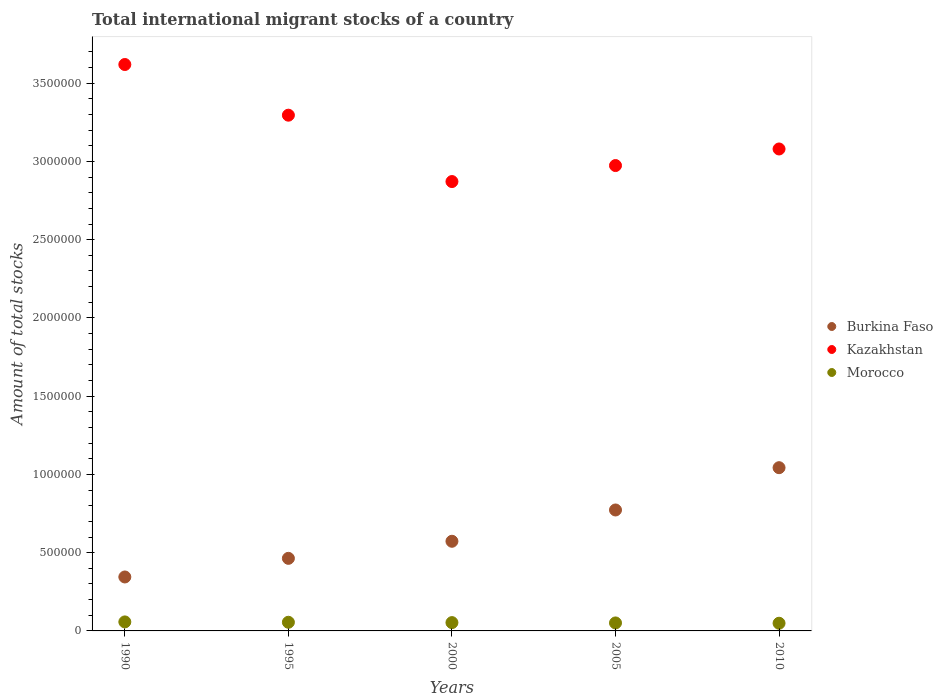How many different coloured dotlines are there?
Provide a short and direct response. 3. Is the number of dotlines equal to the number of legend labels?
Offer a terse response. Yes. What is the amount of total stocks in in Burkina Faso in 1990?
Your answer should be compact. 3.45e+05. Across all years, what is the maximum amount of total stocks in in Kazakhstan?
Provide a succinct answer. 3.62e+06. Across all years, what is the minimum amount of total stocks in in Kazakhstan?
Offer a terse response. 2.87e+06. In which year was the amount of total stocks in in Burkina Faso maximum?
Make the answer very short. 2010. What is the total amount of total stocks in in Morocco in the graph?
Your response must be concise. 2.66e+05. What is the difference between the amount of total stocks in in Burkina Faso in 2000 and that in 2010?
Give a very brief answer. -4.70e+05. What is the difference between the amount of total stocks in in Morocco in 2005 and the amount of total stocks in in Burkina Faso in 2000?
Offer a very short reply. -5.22e+05. What is the average amount of total stocks in in Morocco per year?
Ensure brevity in your answer.  5.32e+04. In the year 2005, what is the difference between the amount of total stocks in in Morocco and amount of total stocks in in Kazakhstan?
Offer a very short reply. -2.92e+06. What is the ratio of the amount of total stocks in in Kazakhstan in 1990 to that in 2000?
Offer a terse response. 1.26. Is the amount of total stocks in in Burkina Faso in 1990 less than that in 2000?
Keep it short and to the point. Yes. Is the difference between the amount of total stocks in in Morocco in 2005 and 2010 greater than the difference between the amount of total stocks in in Kazakhstan in 2005 and 2010?
Offer a terse response. Yes. What is the difference between the highest and the second highest amount of total stocks in in Kazakhstan?
Give a very brief answer. 3.24e+05. What is the difference between the highest and the lowest amount of total stocks in in Kazakhstan?
Your answer should be very brief. 7.48e+05. Is the sum of the amount of total stocks in in Kazakhstan in 1990 and 2010 greater than the maximum amount of total stocks in in Burkina Faso across all years?
Provide a short and direct response. Yes. Does the amount of total stocks in in Kazakhstan monotonically increase over the years?
Your answer should be compact. No. What is the difference between two consecutive major ticks on the Y-axis?
Keep it short and to the point. 5.00e+05. Are the values on the major ticks of Y-axis written in scientific E-notation?
Make the answer very short. No. Where does the legend appear in the graph?
Provide a succinct answer. Center right. How many legend labels are there?
Offer a terse response. 3. What is the title of the graph?
Provide a short and direct response. Total international migrant stocks of a country. Does "Hong Kong" appear as one of the legend labels in the graph?
Your answer should be very brief. No. What is the label or title of the X-axis?
Give a very brief answer. Years. What is the label or title of the Y-axis?
Your response must be concise. Amount of total stocks. What is the Amount of total stocks in Burkina Faso in 1990?
Provide a succinct answer. 3.45e+05. What is the Amount of total stocks of Kazakhstan in 1990?
Ensure brevity in your answer.  3.62e+06. What is the Amount of total stocks in Morocco in 1990?
Ensure brevity in your answer.  5.76e+04. What is the Amount of total stocks in Burkina Faso in 1995?
Give a very brief answer. 4.64e+05. What is the Amount of total stocks in Kazakhstan in 1995?
Provide a succinct answer. 3.30e+06. What is the Amount of total stocks of Morocco in 1995?
Keep it short and to the point. 5.53e+04. What is the Amount of total stocks of Burkina Faso in 2000?
Give a very brief answer. 5.73e+05. What is the Amount of total stocks of Kazakhstan in 2000?
Offer a very short reply. 2.87e+06. What is the Amount of total stocks in Morocco in 2000?
Provide a succinct answer. 5.31e+04. What is the Amount of total stocks of Burkina Faso in 2005?
Give a very brief answer. 7.73e+05. What is the Amount of total stocks in Kazakhstan in 2005?
Give a very brief answer. 2.97e+06. What is the Amount of total stocks of Morocco in 2005?
Provide a short and direct response. 5.10e+04. What is the Amount of total stocks in Burkina Faso in 2010?
Offer a terse response. 1.04e+06. What is the Amount of total stocks of Kazakhstan in 2010?
Your response must be concise. 3.08e+06. What is the Amount of total stocks of Morocco in 2010?
Your answer should be compact. 4.91e+04. Across all years, what is the maximum Amount of total stocks of Burkina Faso?
Ensure brevity in your answer.  1.04e+06. Across all years, what is the maximum Amount of total stocks of Kazakhstan?
Make the answer very short. 3.62e+06. Across all years, what is the maximum Amount of total stocks of Morocco?
Your response must be concise. 5.76e+04. Across all years, what is the minimum Amount of total stocks in Burkina Faso?
Ensure brevity in your answer.  3.45e+05. Across all years, what is the minimum Amount of total stocks in Kazakhstan?
Your response must be concise. 2.87e+06. Across all years, what is the minimum Amount of total stocks in Morocco?
Give a very brief answer. 4.91e+04. What is the total Amount of total stocks of Burkina Faso in the graph?
Provide a short and direct response. 3.20e+06. What is the total Amount of total stocks in Kazakhstan in the graph?
Your response must be concise. 1.58e+07. What is the total Amount of total stocks in Morocco in the graph?
Ensure brevity in your answer.  2.66e+05. What is the difference between the Amount of total stocks in Burkina Faso in 1990 and that in 1995?
Keep it short and to the point. -1.19e+05. What is the difference between the Amount of total stocks in Kazakhstan in 1990 and that in 1995?
Ensure brevity in your answer.  3.24e+05. What is the difference between the Amount of total stocks in Morocco in 1990 and that in 1995?
Keep it short and to the point. 2282. What is the difference between the Amount of total stocks in Burkina Faso in 1990 and that in 2000?
Offer a terse response. -2.28e+05. What is the difference between the Amount of total stocks of Kazakhstan in 1990 and that in 2000?
Make the answer very short. 7.48e+05. What is the difference between the Amount of total stocks in Morocco in 1990 and that in 2000?
Provide a short and direct response. 4473. What is the difference between the Amount of total stocks in Burkina Faso in 1990 and that in 2005?
Give a very brief answer. -4.28e+05. What is the difference between the Amount of total stocks of Kazakhstan in 1990 and that in 2005?
Offer a very short reply. 6.46e+05. What is the difference between the Amount of total stocks in Morocco in 1990 and that in 2005?
Provide a short and direct response. 6577. What is the difference between the Amount of total stocks of Burkina Faso in 1990 and that in 2010?
Keep it short and to the point. -6.98e+05. What is the difference between the Amount of total stocks of Kazakhstan in 1990 and that in 2010?
Provide a short and direct response. 5.40e+05. What is the difference between the Amount of total stocks of Morocco in 1990 and that in 2010?
Offer a terse response. 8499. What is the difference between the Amount of total stocks of Burkina Faso in 1995 and that in 2000?
Provide a succinct answer. -1.09e+05. What is the difference between the Amount of total stocks in Kazakhstan in 1995 and that in 2000?
Give a very brief answer. 4.24e+05. What is the difference between the Amount of total stocks of Morocco in 1995 and that in 2000?
Offer a terse response. 2191. What is the difference between the Amount of total stocks of Burkina Faso in 1995 and that in 2005?
Provide a succinct answer. -3.09e+05. What is the difference between the Amount of total stocks in Kazakhstan in 1995 and that in 2005?
Offer a terse response. 3.22e+05. What is the difference between the Amount of total stocks of Morocco in 1995 and that in 2005?
Give a very brief answer. 4295. What is the difference between the Amount of total stocks of Burkina Faso in 1995 and that in 2010?
Your answer should be very brief. -5.79e+05. What is the difference between the Amount of total stocks in Kazakhstan in 1995 and that in 2010?
Offer a terse response. 2.16e+05. What is the difference between the Amount of total stocks in Morocco in 1995 and that in 2010?
Ensure brevity in your answer.  6217. What is the difference between the Amount of total stocks of Burkina Faso in 2000 and that in 2005?
Offer a terse response. -2.00e+05. What is the difference between the Amount of total stocks in Kazakhstan in 2000 and that in 2005?
Offer a terse response. -1.02e+05. What is the difference between the Amount of total stocks in Morocco in 2000 and that in 2005?
Your answer should be compact. 2104. What is the difference between the Amount of total stocks of Burkina Faso in 2000 and that in 2010?
Offer a very short reply. -4.70e+05. What is the difference between the Amount of total stocks in Kazakhstan in 2000 and that in 2010?
Your answer should be compact. -2.08e+05. What is the difference between the Amount of total stocks in Morocco in 2000 and that in 2010?
Make the answer very short. 4026. What is the difference between the Amount of total stocks in Burkina Faso in 2005 and that in 2010?
Your answer should be very brief. -2.70e+05. What is the difference between the Amount of total stocks of Kazakhstan in 2005 and that in 2010?
Keep it short and to the point. -1.06e+05. What is the difference between the Amount of total stocks of Morocco in 2005 and that in 2010?
Offer a terse response. 1922. What is the difference between the Amount of total stocks in Burkina Faso in 1990 and the Amount of total stocks in Kazakhstan in 1995?
Give a very brief answer. -2.95e+06. What is the difference between the Amount of total stocks in Burkina Faso in 1990 and the Amount of total stocks in Morocco in 1995?
Give a very brief answer. 2.89e+05. What is the difference between the Amount of total stocks in Kazakhstan in 1990 and the Amount of total stocks in Morocco in 1995?
Ensure brevity in your answer.  3.56e+06. What is the difference between the Amount of total stocks of Burkina Faso in 1990 and the Amount of total stocks of Kazakhstan in 2000?
Give a very brief answer. -2.53e+06. What is the difference between the Amount of total stocks in Burkina Faso in 1990 and the Amount of total stocks in Morocco in 2000?
Your answer should be compact. 2.92e+05. What is the difference between the Amount of total stocks of Kazakhstan in 1990 and the Amount of total stocks of Morocco in 2000?
Offer a terse response. 3.57e+06. What is the difference between the Amount of total stocks in Burkina Faso in 1990 and the Amount of total stocks in Kazakhstan in 2005?
Make the answer very short. -2.63e+06. What is the difference between the Amount of total stocks in Burkina Faso in 1990 and the Amount of total stocks in Morocco in 2005?
Provide a short and direct response. 2.94e+05. What is the difference between the Amount of total stocks in Kazakhstan in 1990 and the Amount of total stocks in Morocco in 2005?
Your answer should be very brief. 3.57e+06. What is the difference between the Amount of total stocks of Burkina Faso in 1990 and the Amount of total stocks of Kazakhstan in 2010?
Make the answer very short. -2.73e+06. What is the difference between the Amount of total stocks of Burkina Faso in 1990 and the Amount of total stocks of Morocco in 2010?
Your response must be concise. 2.96e+05. What is the difference between the Amount of total stocks in Kazakhstan in 1990 and the Amount of total stocks in Morocco in 2010?
Ensure brevity in your answer.  3.57e+06. What is the difference between the Amount of total stocks in Burkina Faso in 1995 and the Amount of total stocks in Kazakhstan in 2000?
Provide a succinct answer. -2.41e+06. What is the difference between the Amount of total stocks of Burkina Faso in 1995 and the Amount of total stocks of Morocco in 2000?
Keep it short and to the point. 4.11e+05. What is the difference between the Amount of total stocks in Kazakhstan in 1995 and the Amount of total stocks in Morocco in 2000?
Offer a very short reply. 3.24e+06. What is the difference between the Amount of total stocks of Burkina Faso in 1995 and the Amount of total stocks of Kazakhstan in 2005?
Offer a terse response. -2.51e+06. What is the difference between the Amount of total stocks in Burkina Faso in 1995 and the Amount of total stocks in Morocco in 2005?
Provide a succinct answer. 4.13e+05. What is the difference between the Amount of total stocks in Kazakhstan in 1995 and the Amount of total stocks in Morocco in 2005?
Your response must be concise. 3.24e+06. What is the difference between the Amount of total stocks in Burkina Faso in 1995 and the Amount of total stocks in Kazakhstan in 2010?
Give a very brief answer. -2.62e+06. What is the difference between the Amount of total stocks of Burkina Faso in 1995 and the Amount of total stocks of Morocco in 2010?
Give a very brief answer. 4.15e+05. What is the difference between the Amount of total stocks of Kazakhstan in 1995 and the Amount of total stocks of Morocco in 2010?
Keep it short and to the point. 3.25e+06. What is the difference between the Amount of total stocks of Burkina Faso in 2000 and the Amount of total stocks of Kazakhstan in 2005?
Offer a terse response. -2.40e+06. What is the difference between the Amount of total stocks of Burkina Faso in 2000 and the Amount of total stocks of Morocco in 2005?
Provide a short and direct response. 5.22e+05. What is the difference between the Amount of total stocks of Kazakhstan in 2000 and the Amount of total stocks of Morocco in 2005?
Ensure brevity in your answer.  2.82e+06. What is the difference between the Amount of total stocks of Burkina Faso in 2000 and the Amount of total stocks of Kazakhstan in 2010?
Provide a short and direct response. -2.51e+06. What is the difference between the Amount of total stocks of Burkina Faso in 2000 and the Amount of total stocks of Morocco in 2010?
Keep it short and to the point. 5.24e+05. What is the difference between the Amount of total stocks of Kazakhstan in 2000 and the Amount of total stocks of Morocco in 2010?
Ensure brevity in your answer.  2.82e+06. What is the difference between the Amount of total stocks in Burkina Faso in 2005 and the Amount of total stocks in Kazakhstan in 2010?
Your response must be concise. -2.31e+06. What is the difference between the Amount of total stocks in Burkina Faso in 2005 and the Amount of total stocks in Morocco in 2010?
Give a very brief answer. 7.24e+05. What is the difference between the Amount of total stocks in Kazakhstan in 2005 and the Amount of total stocks in Morocco in 2010?
Your response must be concise. 2.92e+06. What is the average Amount of total stocks of Burkina Faso per year?
Provide a short and direct response. 6.39e+05. What is the average Amount of total stocks of Kazakhstan per year?
Make the answer very short. 3.17e+06. What is the average Amount of total stocks in Morocco per year?
Your response must be concise. 5.32e+04. In the year 1990, what is the difference between the Amount of total stocks of Burkina Faso and Amount of total stocks of Kazakhstan?
Provide a short and direct response. -3.27e+06. In the year 1990, what is the difference between the Amount of total stocks of Burkina Faso and Amount of total stocks of Morocco?
Ensure brevity in your answer.  2.87e+05. In the year 1990, what is the difference between the Amount of total stocks of Kazakhstan and Amount of total stocks of Morocco?
Keep it short and to the point. 3.56e+06. In the year 1995, what is the difference between the Amount of total stocks of Burkina Faso and Amount of total stocks of Kazakhstan?
Your answer should be very brief. -2.83e+06. In the year 1995, what is the difference between the Amount of total stocks of Burkina Faso and Amount of total stocks of Morocco?
Your answer should be compact. 4.08e+05. In the year 1995, what is the difference between the Amount of total stocks in Kazakhstan and Amount of total stocks in Morocco?
Offer a very short reply. 3.24e+06. In the year 2000, what is the difference between the Amount of total stocks of Burkina Faso and Amount of total stocks of Kazakhstan?
Make the answer very short. -2.30e+06. In the year 2000, what is the difference between the Amount of total stocks of Burkina Faso and Amount of total stocks of Morocco?
Offer a terse response. 5.20e+05. In the year 2000, what is the difference between the Amount of total stocks of Kazakhstan and Amount of total stocks of Morocco?
Keep it short and to the point. 2.82e+06. In the year 2005, what is the difference between the Amount of total stocks in Burkina Faso and Amount of total stocks in Kazakhstan?
Offer a very short reply. -2.20e+06. In the year 2005, what is the difference between the Amount of total stocks of Burkina Faso and Amount of total stocks of Morocco?
Offer a very short reply. 7.22e+05. In the year 2005, what is the difference between the Amount of total stocks in Kazakhstan and Amount of total stocks in Morocco?
Give a very brief answer. 2.92e+06. In the year 2010, what is the difference between the Amount of total stocks of Burkina Faso and Amount of total stocks of Kazakhstan?
Offer a terse response. -2.04e+06. In the year 2010, what is the difference between the Amount of total stocks in Burkina Faso and Amount of total stocks in Morocco?
Offer a very short reply. 9.94e+05. In the year 2010, what is the difference between the Amount of total stocks of Kazakhstan and Amount of total stocks of Morocco?
Provide a succinct answer. 3.03e+06. What is the ratio of the Amount of total stocks of Burkina Faso in 1990 to that in 1995?
Offer a terse response. 0.74. What is the ratio of the Amount of total stocks in Kazakhstan in 1990 to that in 1995?
Provide a succinct answer. 1.1. What is the ratio of the Amount of total stocks of Morocco in 1990 to that in 1995?
Ensure brevity in your answer.  1.04. What is the ratio of the Amount of total stocks in Burkina Faso in 1990 to that in 2000?
Give a very brief answer. 0.6. What is the ratio of the Amount of total stocks in Kazakhstan in 1990 to that in 2000?
Your answer should be compact. 1.26. What is the ratio of the Amount of total stocks of Morocco in 1990 to that in 2000?
Provide a short and direct response. 1.08. What is the ratio of the Amount of total stocks of Burkina Faso in 1990 to that in 2005?
Provide a succinct answer. 0.45. What is the ratio of the Amount of total stocks of Kazakhstan in 1990 to that in 2005?
Offer a terse response. 1.22. What is the ratio of the Amount of total stocks of Morocco in 1990 to that in 2005?
Offer a very short reply. 1.13. What is the ratio of the Amount of total stocks in Burkina Faso in 1990 to that in 2010?
Offer a terse response. 0.33. What is the ratio of the Amount of total stocks in Kazakhstan in 1990 to that in 2010?
Your response must be concise. 1.18. What is the ratio of the Amount of total stocks of Morocco in 1990 to that in 2010?
Provide a short and direct response. 1.17. What is the ratio of the Amount of total stocks in Burkina Faso in 1995 to that in 2000?
Ensure brevity in your answer.  0.81. What is the ratio of the Amount of total stocks in Kazakhstan in 1995 to that in 2000?
Provide a succinct answer. 1.15. What is the ratio of the Amount of total stocks in Morocco in 1995 to that in 2000?
Give a very brief answer. 1.04. What is the ratio of the Amount of total stocks in Burkina Faso in 1995 to that in 2005?
Offer a terse response. 0.6. What is the ratio of the Amount of total stocks of Kazakhstan in 1995 to that in 2005?
Provide a succinct answer. 1.11. What is the ratio of the Amount of total stocks of Morocco in 1995 to that in 2005?
Make the answer very short. 1.08. What is the ratio of the Amount of total stocks in Burkina Faso in 1995 to that in 2010?
Provide a succinct answer. 0.44. What is the ratio of the Amount of total stocks in Kazakhstan in 1995 to that in 2010?
Make the answer very short. 1.07. What is the ratio of the Amount of total stocks of Morocco in 1995 to that in 2010?
Offer a terse response. 1.13. What is the ratio of the Amount of total stocks of Burkina Faso in 2000 to that in 2005?
Ensure brevity in your answer.  0.74. What is the ratio of the Amount of total stocks in Kazakhstan in 2000 to that in 2005?
Provide a short and direct response. 0.97. What is the ratio of the Amount of total stocks of Morocco in 2000 to that in 2005?
Offer a very short reply. 1.04. What is the ratio of the Amount of total stocks of Burkina Faso in 2000 to that in 2010?
Ensure brevity in your answer.  0.55. What is the ratio of the Amount of total stocks of Kazakhstan in 2000 to that in 2010?
Keep it short and to the point. 0.93. What is the ratio of the Amount of total stocks of Morocco in 2000 to that in 2010?
Your response must be concise. 1.08. What is the ratio of the Amount of total stocks in Burkina Faso in 2005 to that in 2010?
Your answer should be very brief. 0.74. What is the ratio of the Amount of total stocks of Kazakhstan in 2005 to that in 2010?
Make the answer very short. 0.97. What is the ratio of the Amount of total stocks of Morocco in 2005 to that in 2010?
Provide a succinct answer. 1.04. What is the difference between the highest and the second highest Amount of total stocks in Burkina Faso?
Offer a terse response. 2.70e+05. What is the difference between the highest and the second highest Amount of total stocks in Kazakhstan?
Offer a terse response. 3.24e+05. What is the difference between the highest and the second highest Amount of total stocks of Morocco?
Give a very brief answer. 2282. What is the difference between the highest and the lowest Amount of total stocks in Burkina Faso?
Your response must be concise. 6.98e+05. What is the difference between the highest and the lowest Amount of total stocks of Kazakhstan?
Provide a short and direct response. 7.48e+05. What is the difference between the highest and the lowest Amount of total stocks in Morocco?
Your answer should be very brief. 8499. 